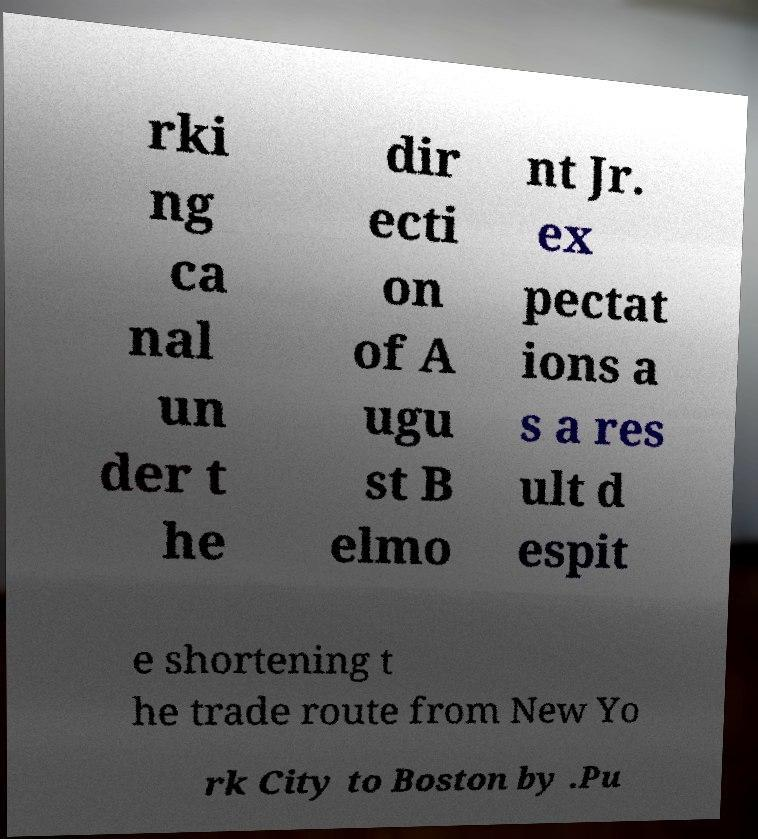Can you accurately transcribe the text from the provided image for me? rki ng ca nal un der t he dir ecti on of A ugu st B elmo nt Jr. ex pectat ions a s a res ult d espit e shortening t he trade route from New Yo rk City to Boston by .Pu 